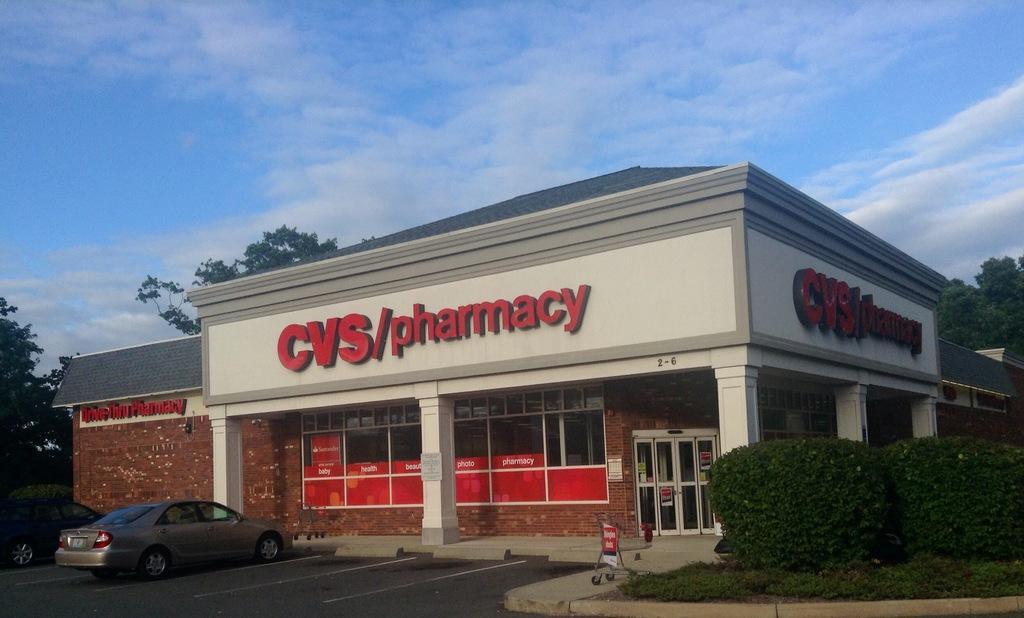Could you give a brief overview of what you see in this image? This picture is clicked outside the city. In this picture, we see two cars parked on the road. Beside cars, we see a building in white and brown color with a grey color roof. On top of the building, it is written as "CVS/pharmacy". In front of the building, we see a board in red color. On the right side, we see the shrubs and the grass. There are trees in the background. At the top of the picture, we see the sky, which is blue in color. 